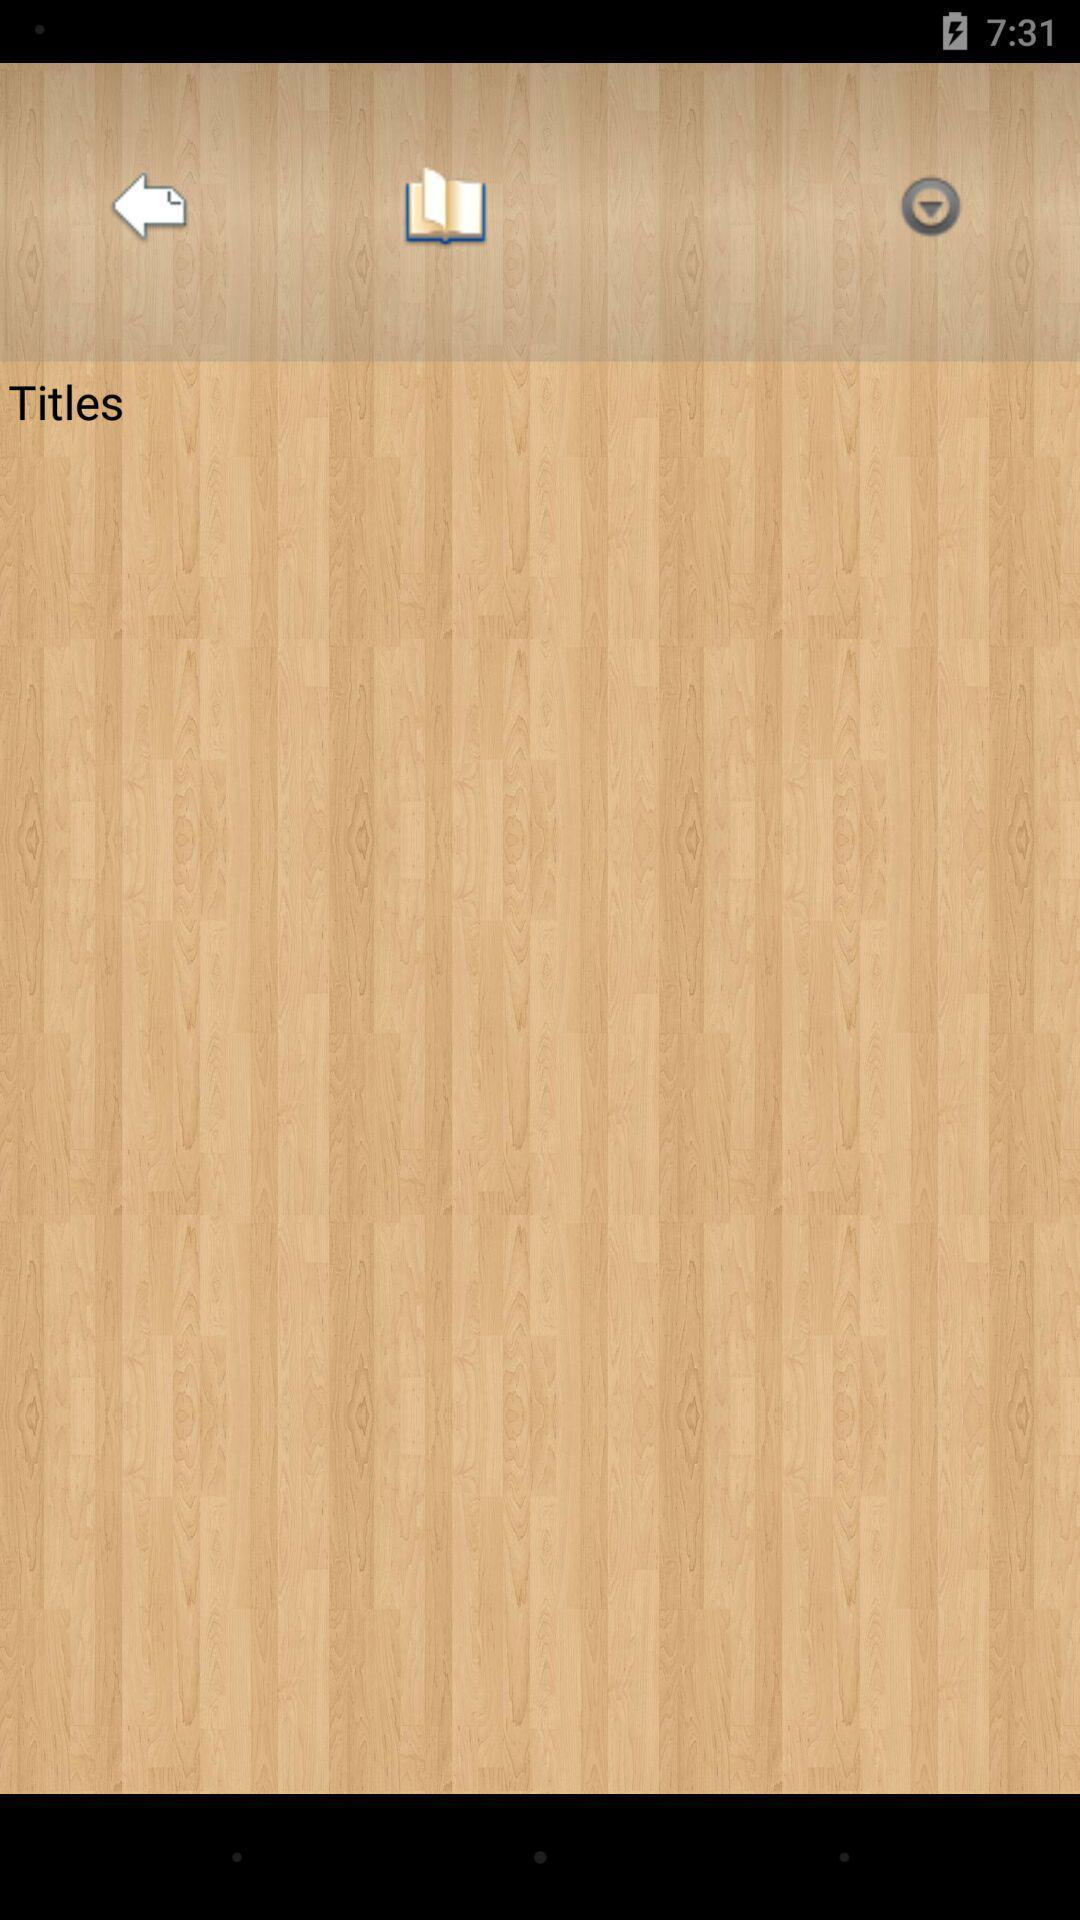Describe the content in this image. Page displaying titles and options of book reading app. 